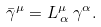Convert formula to latex. <formula><loc_0><loc_0><loc_500><loc_500>\bar { \gamma } ^ { \mu } = L ^ { \mu } _ { \, \alpha } \, \gamma ^ { \alpha } .</formula> 